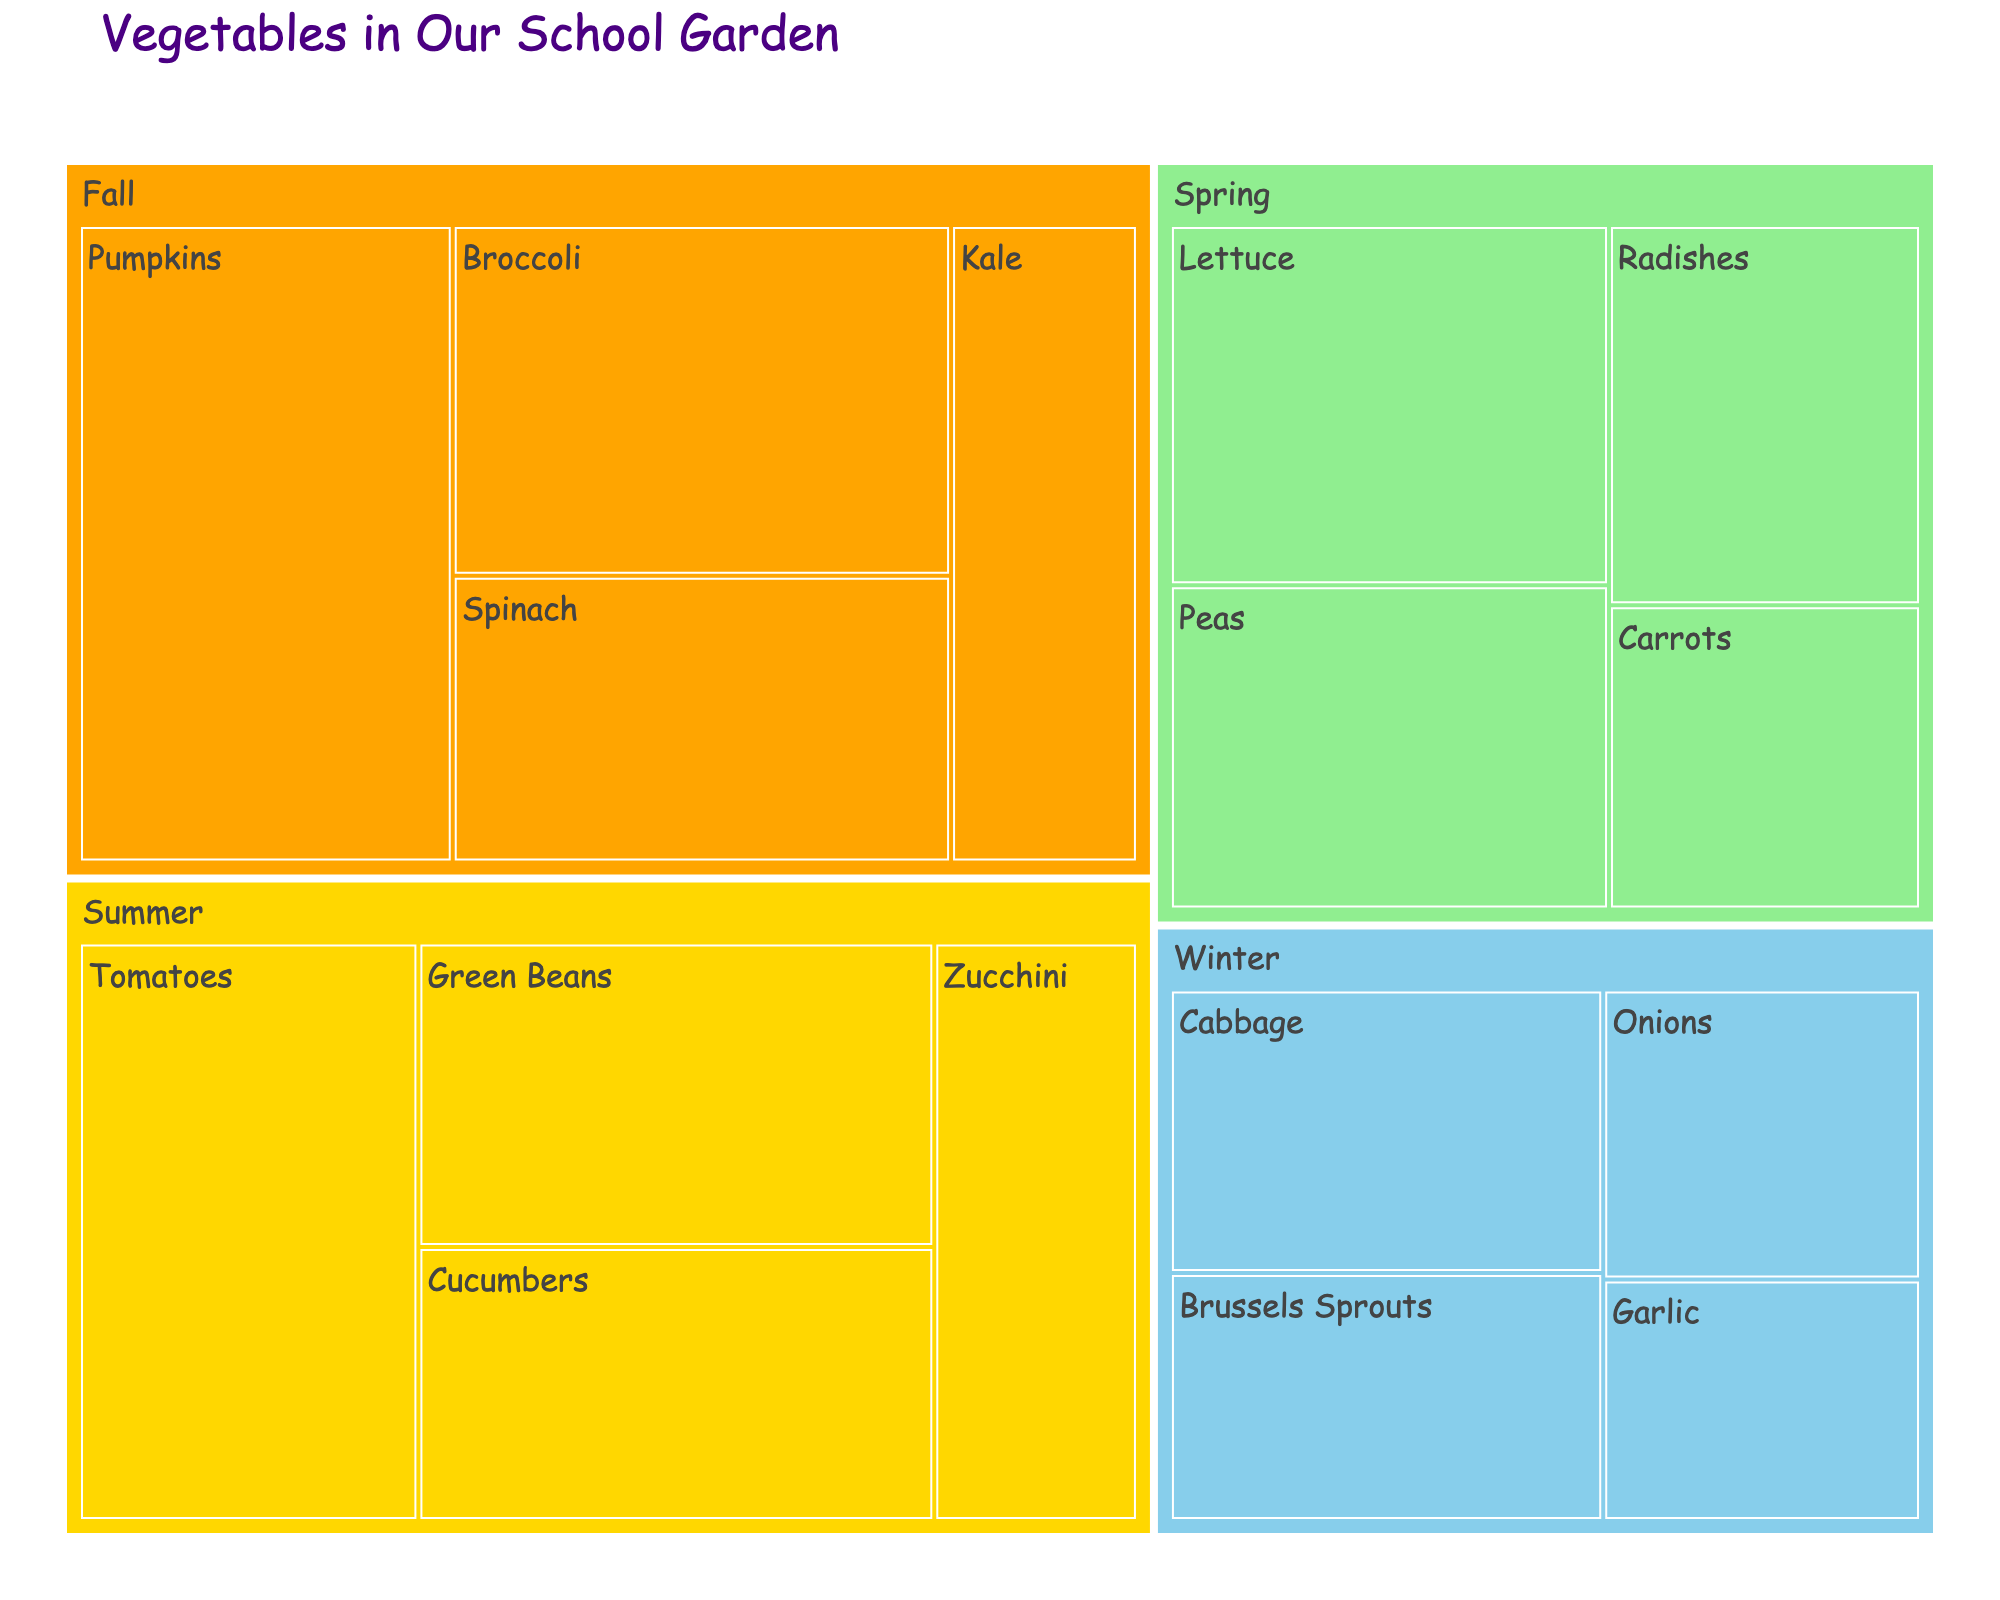Which season has the vegetable with the largest area? To find the vegetable with the largest area, look at the relative sizes of the sections in the treemap. The largest section is "Pumpkins" in the Fall, covering 30 sq ft.
Answer: Fall How many vegetables are grown in the Summer? Count the number of individual sections labeled under "Summer" in the treemap. There are 4 vegetables: Tomatoes, Cucumbers, Green Beans, and Zucchini.
Answer: 4 What is the total area of vegetables grown in the Winter? Sum the areas of all vegetables listed under "Winter". The areas are: Garlic (10), Onions (12), Brussels Sprouts (14), and Cabbage (16). Therefore, the total area is 10 + 12 + 14 + 16 = 52 sq ft.
Answer: 52 sq ft Which vegetable has a larger area: Carrots or Kale? Compare the areas of "Carrots" and "Kale" from the treemap. Carrots have an area of 12 sq ft, and Kale has an area of 15 sq ft. Hence, Kale has a larger area.
Answer: Kale What is the title of the figure? Look at the top of the treemap where the title is displayed. The title is "Vegetables in Our School Garden".
Answer: Vegetables in Our School Garden What is the smallest area of a vegetable grown in any season? Identify the section with the smallest area by comparing the numerical values. Garlic in Winter has the smallest area, which is 10 sq ft.
Answer: 10 sq ft How do the areas of Lettuce and Peas compare? Compare the areas listed for Lettuce and Peas. Lettuce has an area of 20 sq ft, while Peas have an area of 18 sq ft. Lettuce covers more area than Peas.
Answer: Lettuce has a larger area What colors represent the seasons in the treemap? Identify the colors used in the treemap to distinguish different seasons. Spring is light green, Summer is gold, Fall is orange, and Winter is light blue.
Answer: Spring (light green), Summer (gold), Fall (orange), Winter (light blue) What is the combined area of all vegetables grown in the Spring? Add the areas of all Spring vegetables: Lettuce (20), Radishes (15), Peas (18), Carrots (12). Total area is 20 + 15 + 18 + 12 = 65 sq ft.
Answer: 65 sq ft Which season has the least total area of vegetables grown? Calculate the total area for each season and compare. Spring: 65 sq ft, Summer: 78 sq ft, Fall: 85 sq ft, Winter: 52 sq ft. Winter has the least total area of vegetables grown.
Answer: Winter 